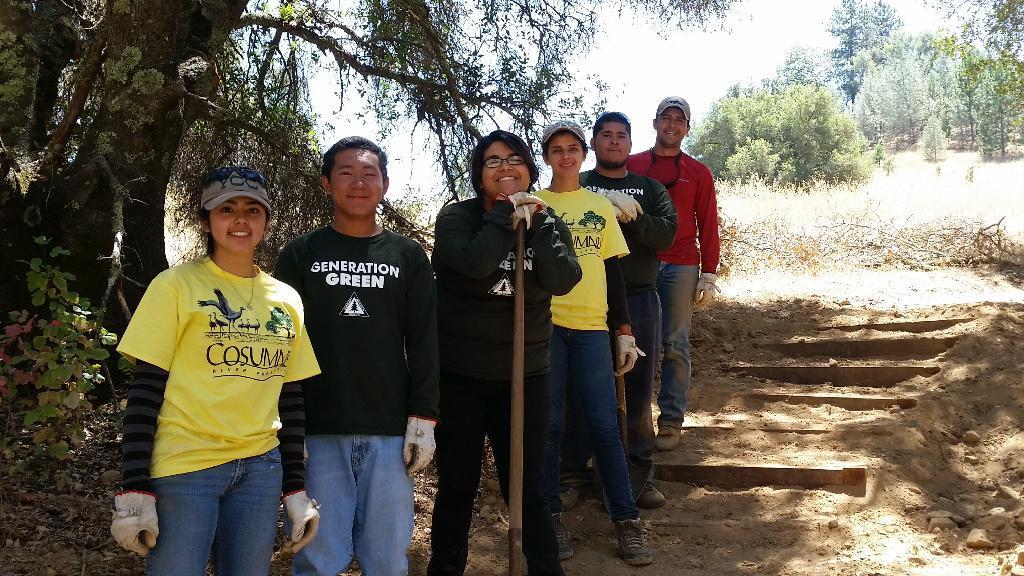Please provide a concise description of this image. In the center of the image we can see people standing and smiling. In the background there are trees and sky. On the right we can see stairs. 